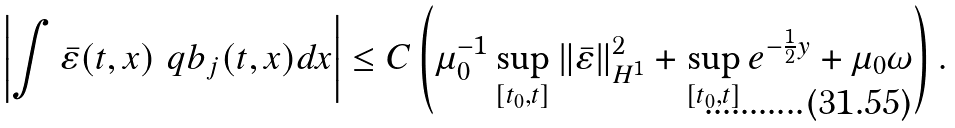Convert formula to latex. <formula><loc_0><loc_0><loc_500><loc_500>\left | \int { \bar { \varepsilon } } ( t , x ) \ q b _ { j } ( t , x ) d x \right | \leq C \left ( \mu _ { 0 } ^ { - 1 } \sup _ { [ t _ { 0 } , t ] } \| { \bar { \varepsilon } } \| _ { H ^ { 1 } } ^ { 2 } + \sup _ { [ t _ { 0 } , t ] } e ^ { - \frac { 1 } { 2 } y } + \mu _ { 0 } \omega \right ) .</formula> 